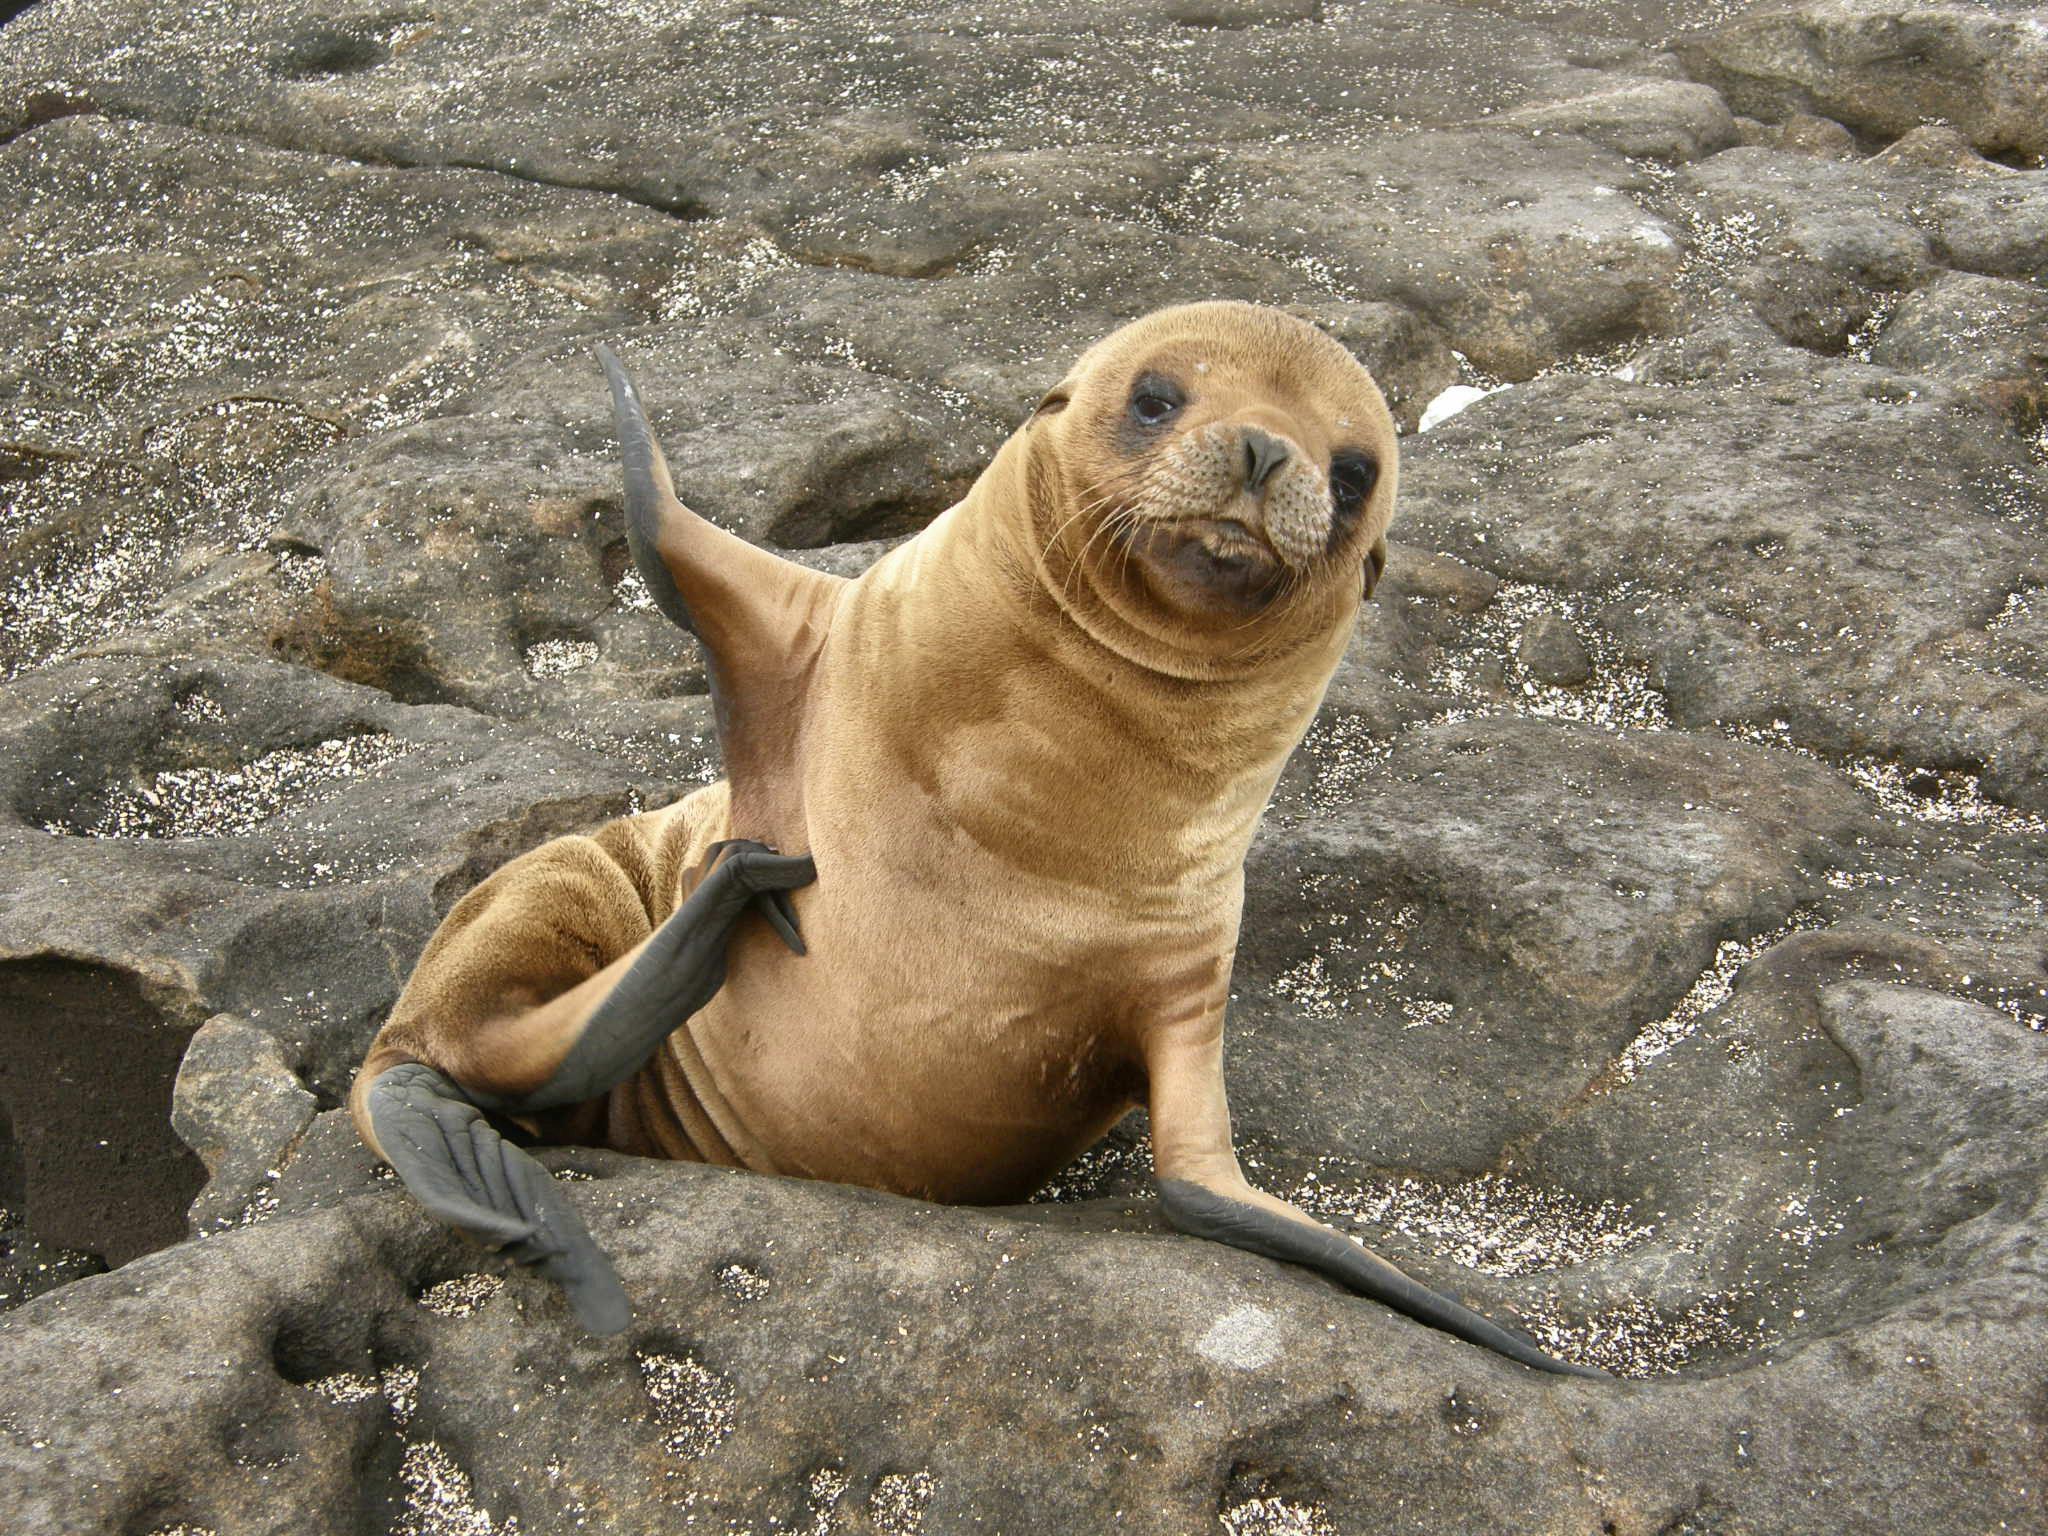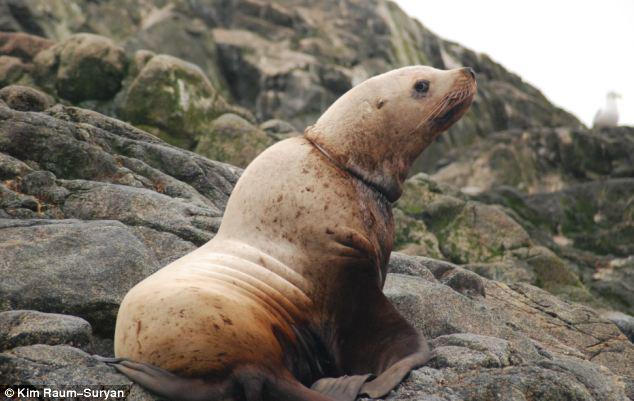The first image is the image on the left, the second image is the image on the right. Given the left and right images, does the statement "At least one seal is showing its teeth." hold true? Answer yes or no. No. The first image is the image on the left, the second image is the image on the right. Considering the images on both sides, is "One of the seals has his mouth open in the left image." valid? Answer yes or no. No. 